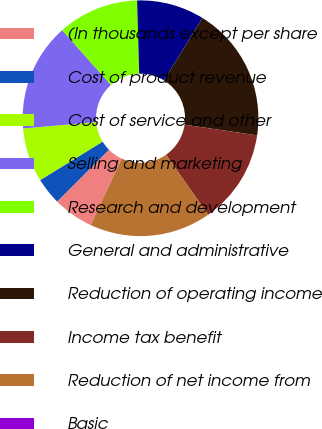Convert chart to OTSL. <chart><loc_0><loc_0><loc_500><loc_500><pie_chart><fcel>(In thousands except per share<fcel>Cost of product revenue<fcel>Cost of service and other<fcel>Selling and marketing<fcel>Research and development<fcel>General and administrative<fcel>Reduction of operating income<fcel>Income tax benefit<fcel>Reduction of net income from<fcel>Basic<nl><fcel>5.56%<fcel>3.7%<fcel>7.41%<fcel>14.81%<fcel>11.11%<fcel>9.26%<fcel>18.52%<fcel>12.96%<fcel>16.67%<fcel>0.0%<nl></chart> 